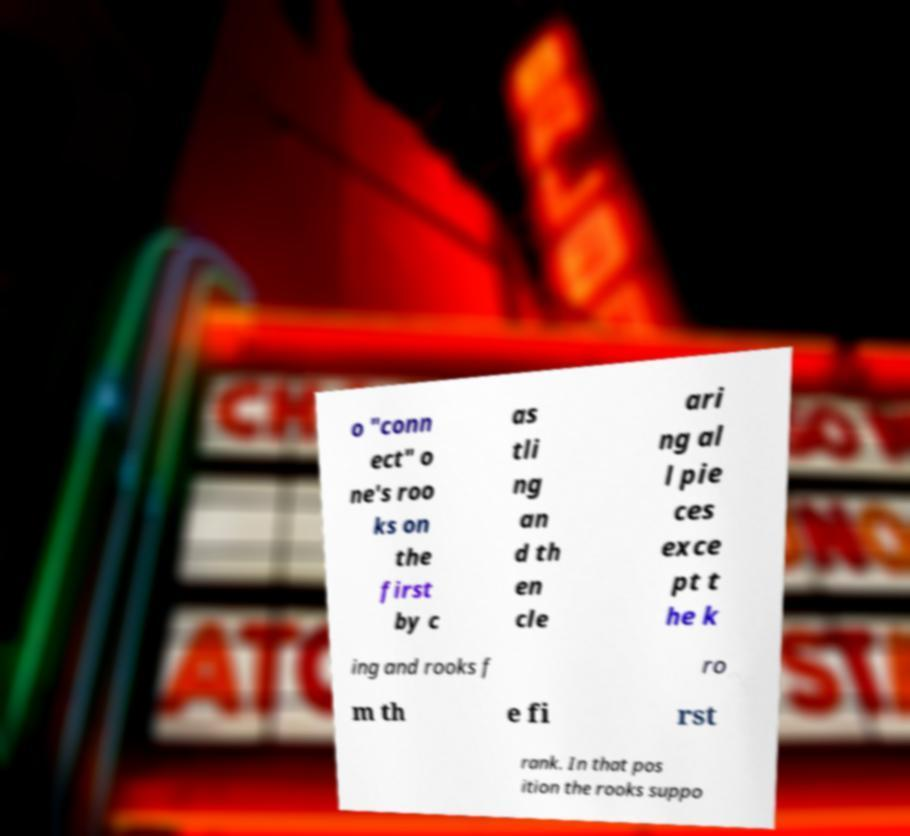I need the written content from this picture converted into text. Can you do that? o "conn ect" o ne's roo ks on the first by c as tli ng an d th en cle ari ng al l pie ces exce pt t he k ing and rooks f ro m th e fi rst rank. In that pos ition the rooks suppo 